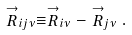Convert formula to latex. <formula><loc_0><loc_0><loc_500><loc_500>\stackrel { \rightarrow } { R } _ { i j \nu } \equiv \stackrel { \rightarrow } { R } _ { i \nu } - \stackrel { \rightarrow } { R } _ { j \nu } .</formula> 